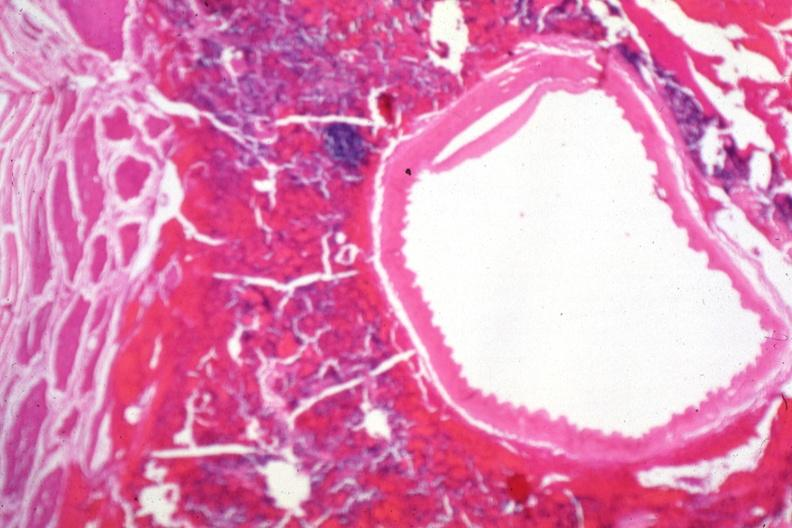what is present?
Answer the question using a single word or phrase. Pituitary 